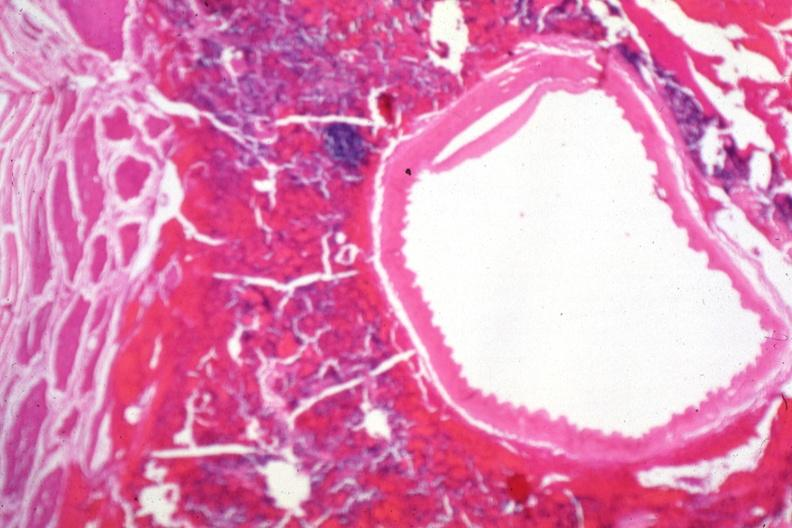what is present?
Answer the question using a single word or phrase. Pituitary 